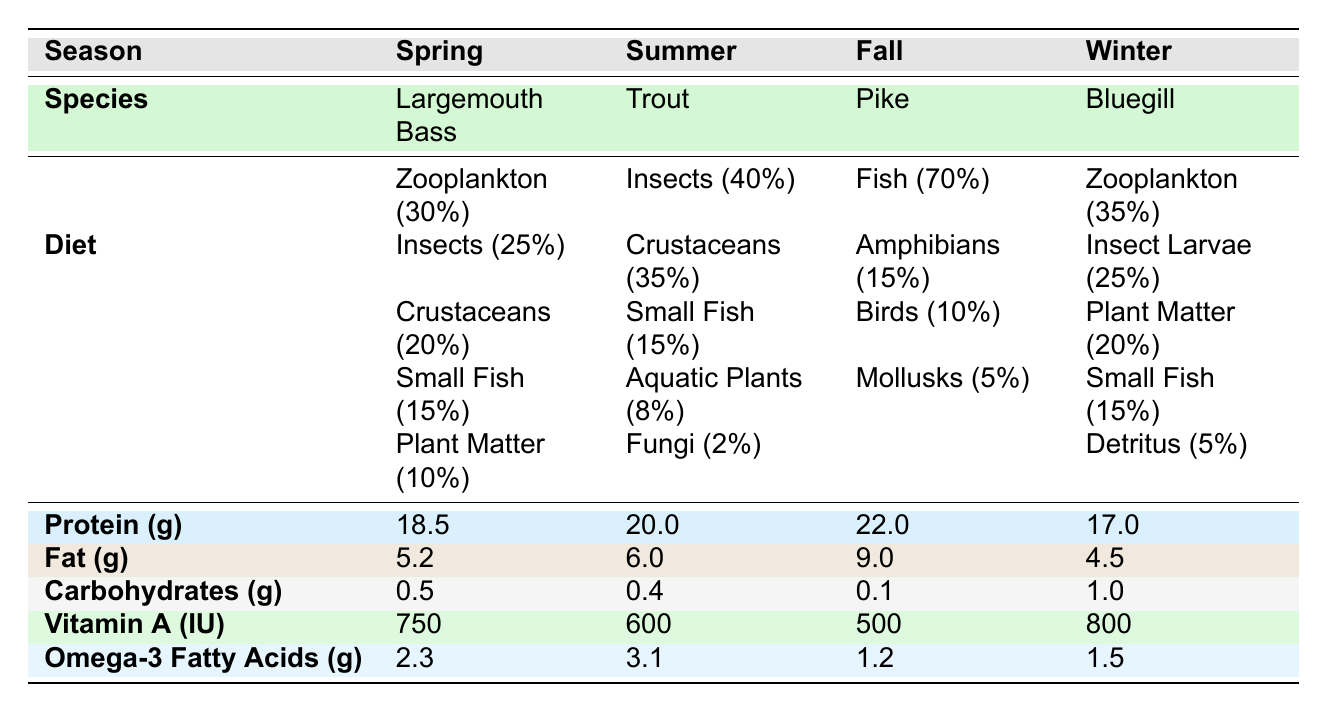What is the primary diet of the Pike in the Fall? The table indicates that the Pike's diet is primarily composed of Fish (70%). This is the first food item listed under the diet for the Pike in the Fall season.
Answer: Fish (70%) Which fish species has the highest protein content and what is the value? Looking at the protein values in the nutrient profile, Pike has the highest protein content at 22.0 grams. This can be found in the row corresponding to the Fall season.
Answer: 22.0 Does Bluegill have a higher carbohydrate content than Trout? The table shows that Bluegill has 1.0 grams of carbohydrates, while Trout has 0.4 grams. Since 1.0 is greater than 0.4, the answer is yes.
Answer: Yes What is the total percentage of food items for Largemouth Bass in Spring? The percentages of food items for Largemouth Bass are: Zooplankton (30%), Insects (25%), Crustaceans (20%), Small Fish (15%), and Plant Matter (10%). Adding these together gives 30 + 25 + 20 + 15 + 10 = 100%.
Answer: 100% Which season shows the lowest fat content and what is that value? By comparing the fat content across the seasons, we see that Bluegill in Winter has the lowest fat content at 4.5 grams. This can be examined in the nutrient profile row for each season.
Answer: 4.5 Is the omega-3 fatty acid content in Trout higher than in Bluegill? The omega-3 fatty acid content for Trout is 3.1 grams and for Bluegill, it is 1.5 grams. Since 3.1 is greater than 1.5, the answer is yes.
Answer: Yes What is the average protein content for all four species listed? The protein contents are 18.5 (Largemouth Bass), 20.0 (Trout), 22.0 (Pike), and 17.0 (Bluegill). To find the average, sum these values: 18.5 + 20.0 + 22.0 + 17.0 = 77.5. Then divide by 4 (the number of species), resulting in an average protein content of 77.5 / 4 = 19.375 grams.
Answer: 19.375 Which food item contributes the most to the diet of Trout during Summer? The table indicates that the food item Insects contributes the most to the diet of Trout in Summer with a percentage of 40%, as it is the first food item listed for this species in that season.
Answer: Insects (40%) Does Largemouth Bass predominantly eat plant matter in Spring? The diet percentages for Largemouth Bass shows Plant Matter at 10%, which is significantly lower than the other food item percentages. Therefore, it does not predominantly eat plant matter, as 10% is a small proportion.
Answer: No 